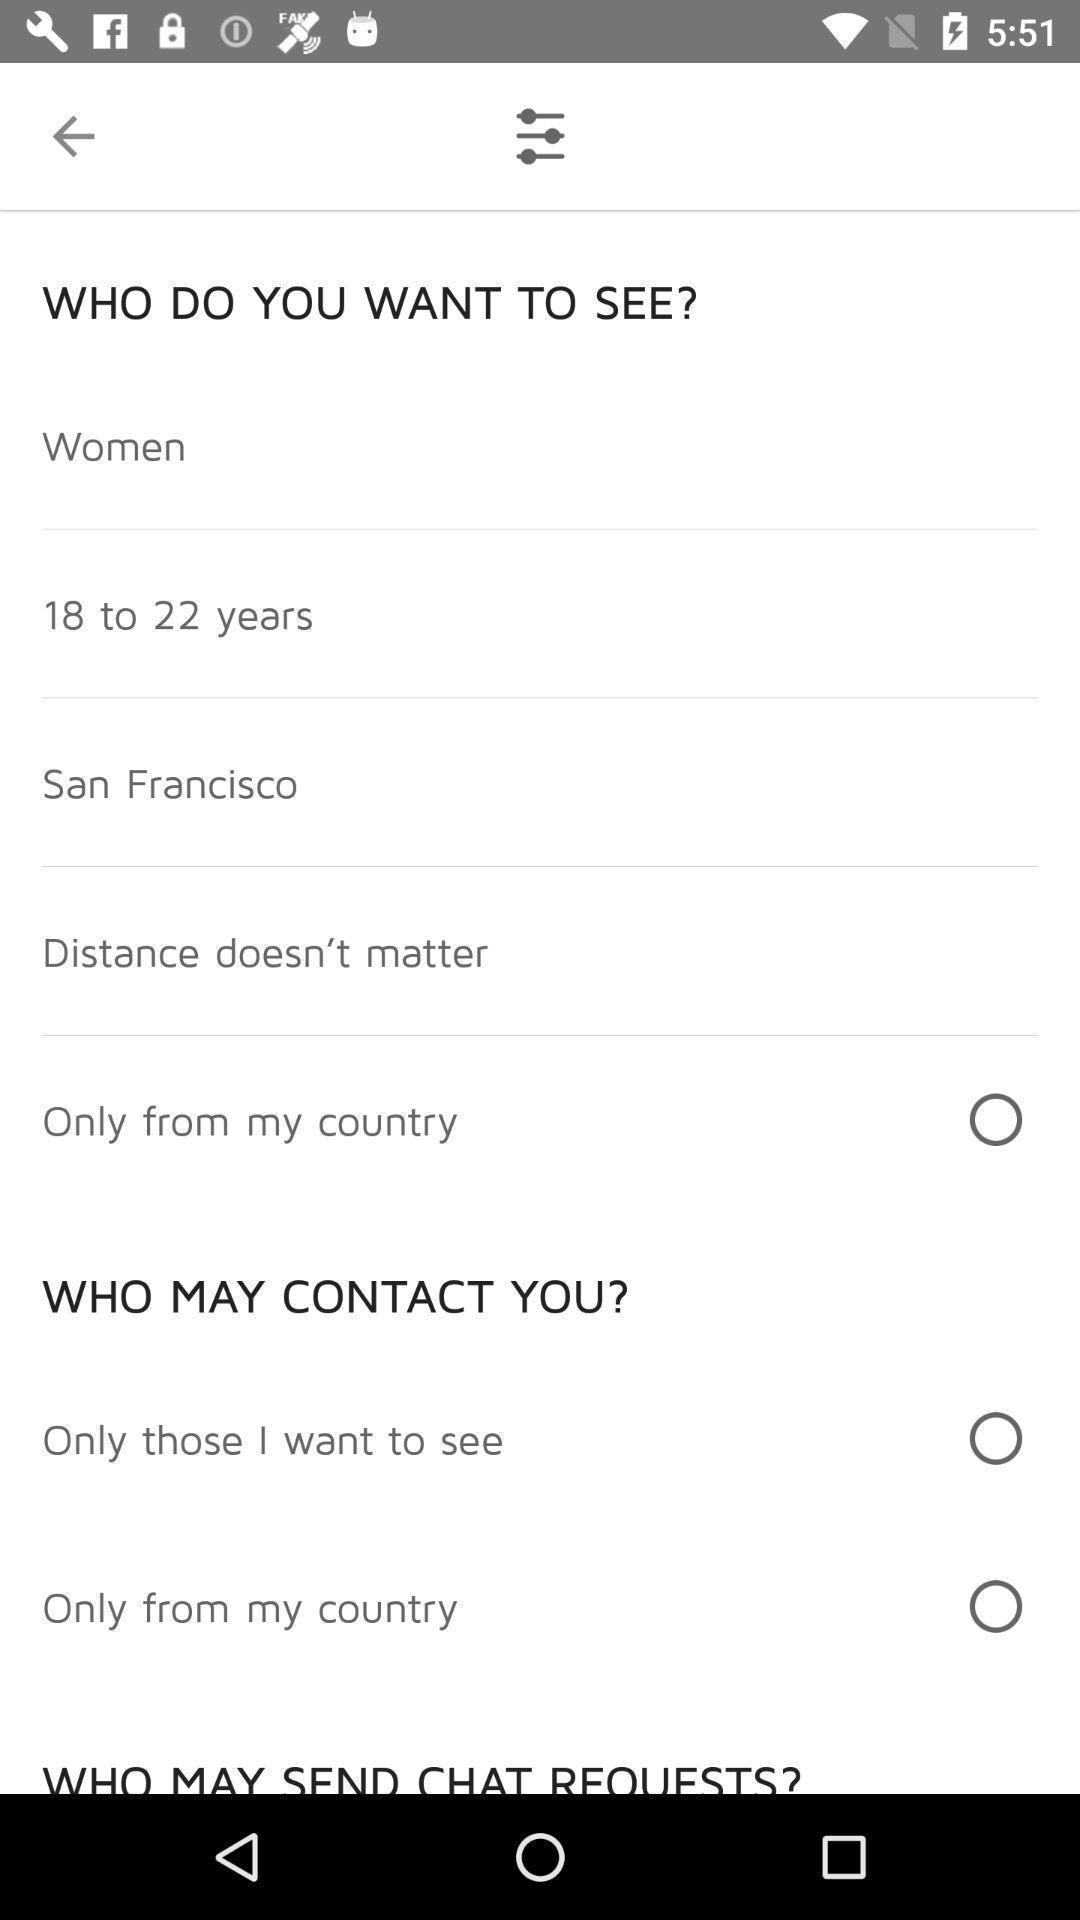What details can you identify in this image? Screen displaying description for searching female. 